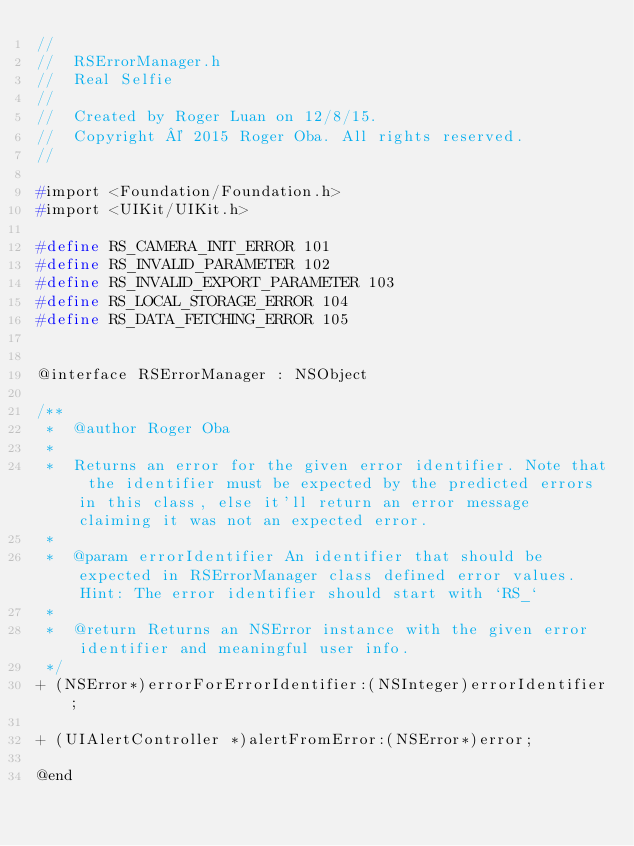Convert code to text. <code><loc_0><loc_0><loc_500><loc_500><_C_>//
//  RSErrorManager.h
//  Real Selfie
//
//  Created by Roger Luan on 12/8/15.
//  Copyright © 2015 Roger Oba. All rights reserved.
//

#import <Foundation/Foundation.h>
#import <UIKit/UIKit.h>

#define RS_CAMERA_INIT_ERROR 101
#define RS_INVALID_PARAMETER 102
#define RS_INVALID_EXPORT_PARAMETER 103
#define RS_LOCAL_STORAGE_ERROR 104
#define RS_DATA_FETCHING_ERROR 105


@interface RSErrorManager : NSObject

/**
 *  @author Roger Oba
 *
 *  Returns an error for the given error identifier. Note that the identifier must be expected by the predicted errors in this class, else it'll return an error message claiming it was not an expected error.
 *
 *  @param errorIdentifier An identifier that should be expected in RSErrorManager class defined error values. Hint: The error identifier should start with `RS_`
 *
 *  @return Returns an NSError instance with the given error identifier and meaningful user info.
 */
+ (NSError*)errorForErrorIdentifier:(NSInteger)errorIdentifier;

+ (UIAlertController *)alertFromError:(NSError*)error;

@end
</code> 